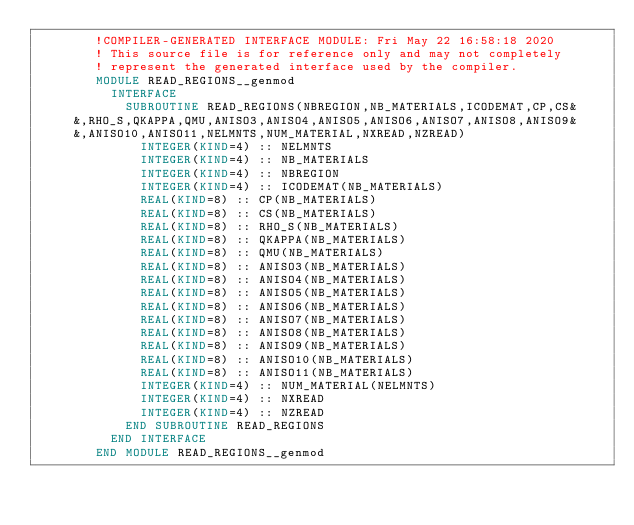<code> <loc_0><loc_0><loc_500><loc_500><_FORTRAN_>        !COMPILER-GENERATED INTERFACE MODULE: Fri May 22 16:58:18 2020
        ! This source file is for reference only and may not completely
        ! represent the generated interface used by the compiler.
        MODULE READ_REGIONS__genmod
          INTERFACE 
            SUBROUTINE READ_REGIONS(NBREGION,NB_MATERIALS,ICODEMAT,CP,CS&
     &,RHO_S,QKAPPA,QMU,ANISO3,ANISO4,ANISO5,ANISO6,ANISO7,ANISO8,ANISO9&
     &,ANISO10,ANISO11,NELMNTS,NUM_MATERIAL,NXREAD,NZREAD)
              INTEGER(KIND=4) :: NELMNTS
              INTEGER(KIND=4) :: NB_MATERIALS
              INTEGER(KIND=4) :: NBREGION
              INTEGER(KIND=4) :: ICODEMAT(NB_MATERIALS)
              REAL(KIND=8) :: CP(NB_MATERIALS)
              REAL(KIND=8) :: CS(NB_MATERIALS)
              REAL(KIND=8) :: RHO_S(NB_MATERIALS)
              REAL(KIND=8) :: QKAPPA(NB_MATERIALS)
              REAL(KIND=8) :: QMU(NB_MATERIALS)
              REAL(KIND=8) :: ANISO3(NB_MATERIALS)
              REAL(KIND=8) :: ANISO4(NB_MATERIALS)
              REAL(KIND=8) :: ANISO5(NB_MATERIALS)
              REAL(KIND=8) :: ANISO6(NB_MATERIALS)
              REAL(KIND=8) :: ANISO7(NB_MATERIALS)
              REAL(KIND=8) :: ANISO8(NB_MATERIALS)
              REAL(KIND=8) :: ANISO9(NB_MATERIALS)
              REAL(KIND=8) :: ANISO10(NB_MATERIALS)
              REAL(KIND=8) :: ANISO11(NB_MATERIALS)
              INTEGER(KIND=4) :: NUM_MATERIAL(NELMNTS)
              INTEGER(KIND=4) :: NXREAD
              INTEGER(KIND=4) :: NZREAD
            END SUBROUTINE READ_REGIONS
          END INTERFACE 
        END MODULE READ_REGIONS__genmod
</code> 